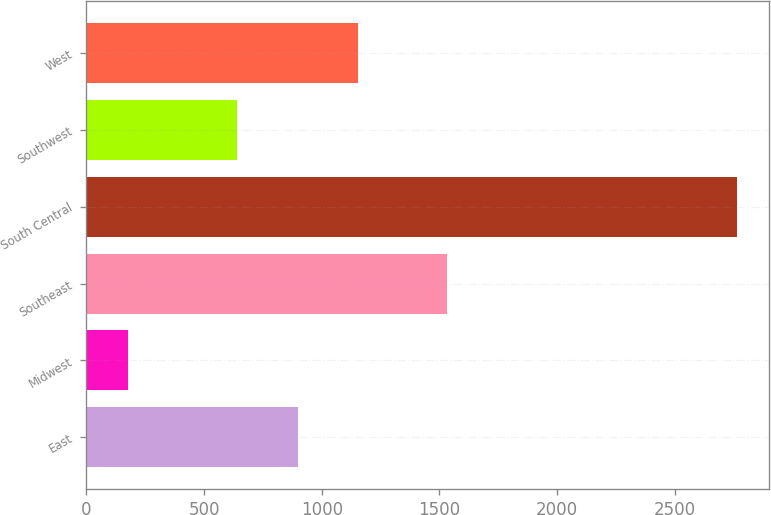Convert chart. <chart><loc_0><loc_0><loc_500><loc_500><bar_chart><fcel>East<fcel>Midwest<fcel>Southeast<fcel>South Central<fcel>Southwest<fcel>West<nl><fcel>897.6<fcel>177<fcel>1531<fcel>2763<fcel>639<fcel>1156.2<nl></chart> 